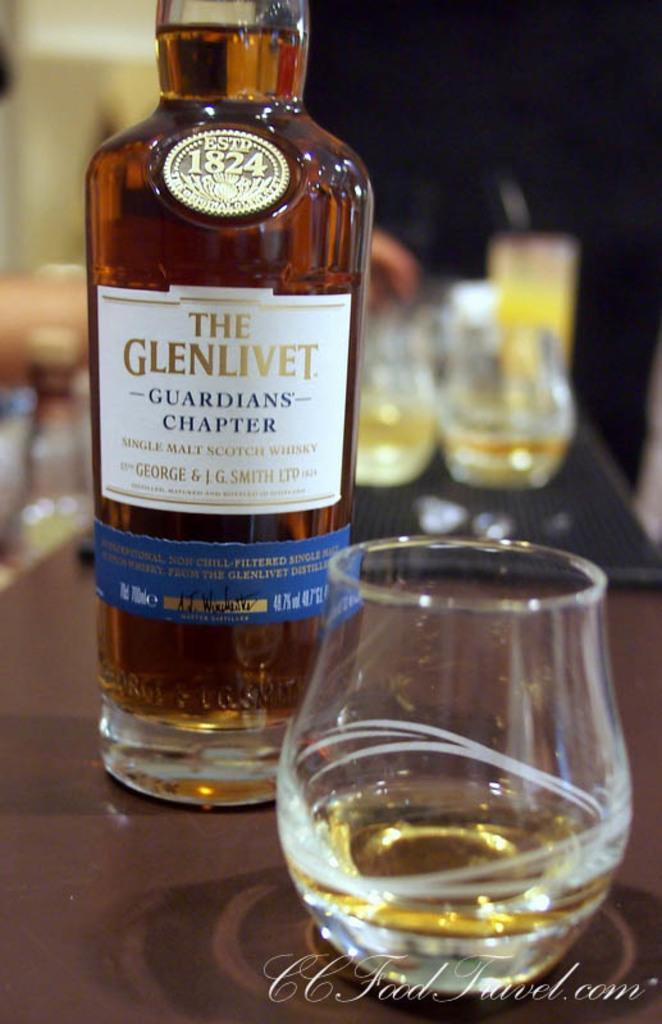Provide a one-sentence caption for the provided image. A bottle of The Glenlivet guarians chapter whiskey sits next to a glass. 